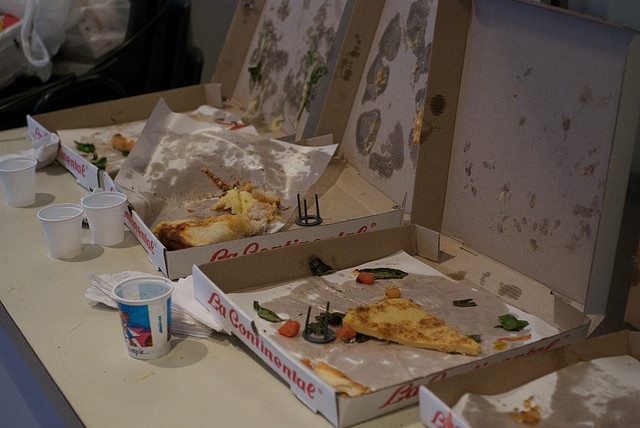Describe the objects in this image and their specific colors. I can see dining table in gray and darkgray tones, pizza in gray, olive, and maroon tones, pizza in gray, olive, tan, and maroon tones, cup in gray, darkgray, and blue tones, and cup in gray tones in this image. 